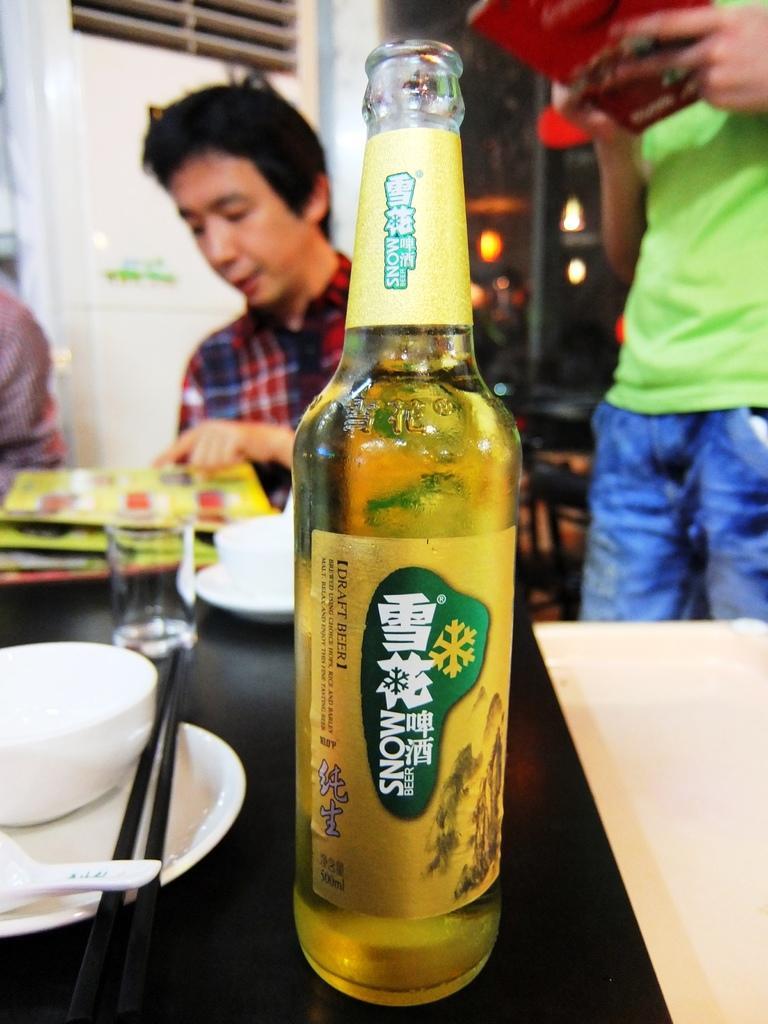How would you summarize this image in a sentence or two? In this image in the center there is one bottle and that bottle is filled with drink. On the background there is one person who is sitting and on the right side there is one person who is standing and on the left side there are some cups, spoons, plates, and chopsticks are there and one glass is there. 